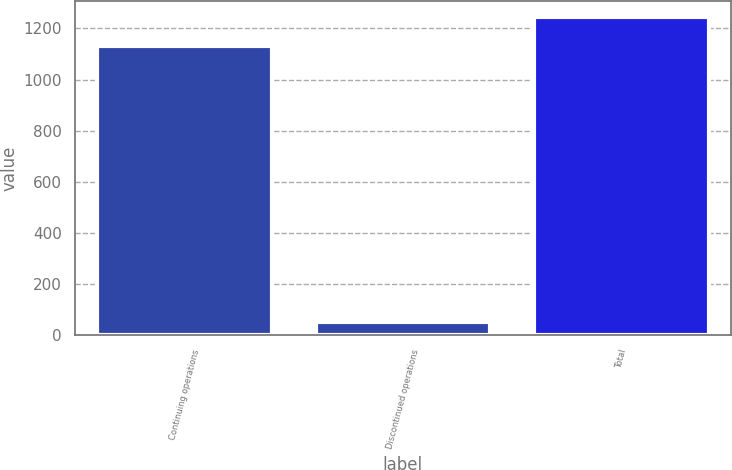Convert chart. <chart><loc_0><loc_0><loc_500><loc_500><bar_chart><fcel>Continuing operations<fcel>Discontinued operations<fcel>Total<nl><fcel>1131<fcel>53<fcel>1244.1<nl></chart> 